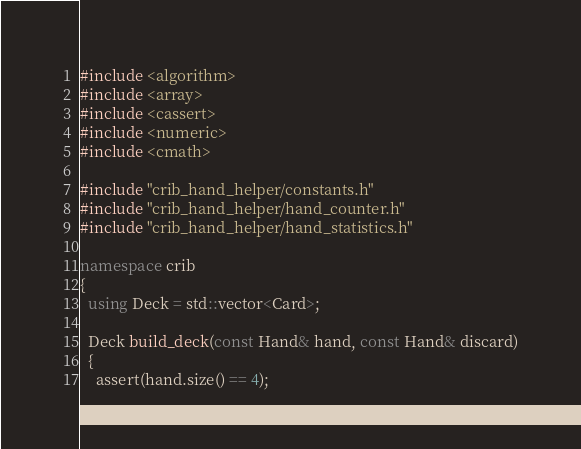Convert code to text. <code><loc_0><loc_0><loc_500><loc_500><_C++_>#include <algorithm>
#include <array>
#include <cassert>
#include <numeric>
#include <cmath>

#include "crib_hand_helper/constants.h"
#include "crib_hand_helper/hand_counter.h"
#include "crib_hand_helper/hand_statistics.h"

namespace crib
{
  using Deck = std::vector<Card>;

  Deck build_deck(const Hand& hand, const Hand& discard)
  {
    assert(hand.size() == 4);</code> 